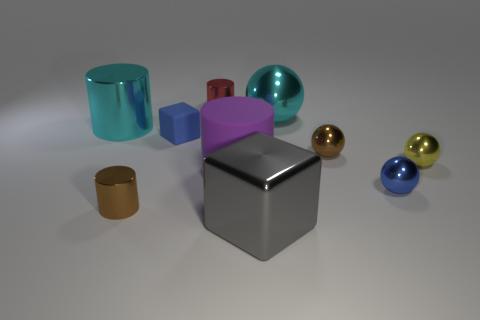Do the large purple object and the ball in front of the large matte object have the same material?
Ensure brevity in your answer.  No. Is the number of gray shiny blocks that are behind the yellow thing less than the number of shiny cylinders?
Ensure brevity in your answer.  Yes. What number of other objects are there of the same shape as the big purple object?
Your answer should be compact. 3. Is there any other thing that has the same color as the large matte cylinder?
Give a very brief answer. No. Do the big rubber cylinder and the rubber object left of the red cylinder have the same color?
Provide a succinct answer. No. How many other objects are there of the same size as the brown ball?
Provide a succinct answer. 5. What size is the ball that is the same color as the matte block?
Offer a terse response. Small. What number of balls are large gray metal things or cyan shiny things?
Your answer should be very brief. 1. There is a large cyan object in front of the big cyan ball; is its shape the same as the small yellow shiny object?
Provide a short and direct response. No. Is the number of blue metal spheres behind the tiny brown shiny ball greater than the number of brown metal objects?
Your answer should be compact. No. 